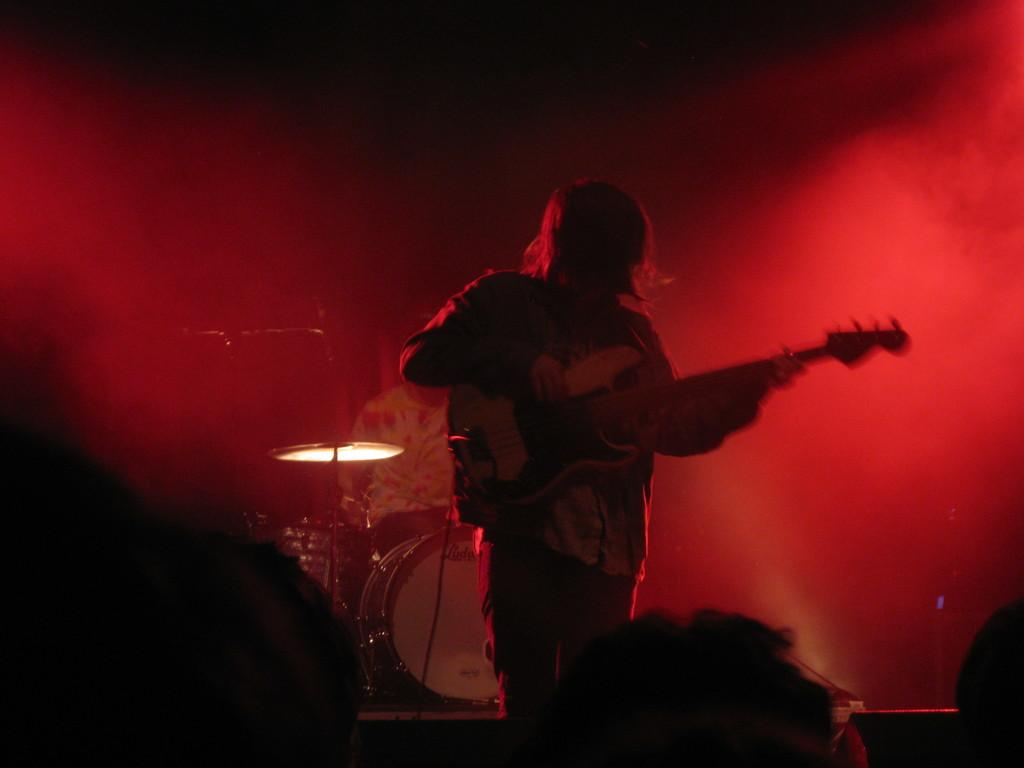What is there is a man performing on a stage in the image. What is he doing? The man is playing a guitar. Are there any other musicians on the stage with him? Yes, there is another person playing a musical instrument behind the man on the stage. Can you see any cherries being used as part of the performance in the image? There are no cherries present in the image. Is the stage located downtown in the image? The location of the stage is not mentioned in the provided facts, so it cannot be determined if it is downtown or not. 